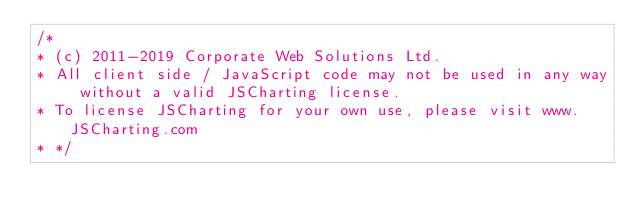Convert code to text. <code><loc_0><loc_0><loc_500><loc_500><_JavaScript_>/*
* (c) 2011-2019 Corporate Web Solutions Ltd. 
* All client side / JavaScript code may not be used in any way without a valid JSCharting license.
* To license JSCharting for your own use, please visit www.JSCharting.com
* */</code> 